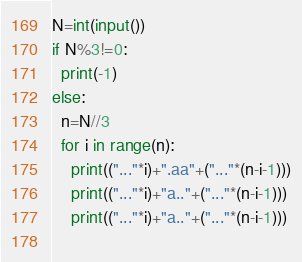Convert code to text. <code><loc_0><loc_0><loc_500><loc_500><_Python_>N=int(input())
if N%3!=0:
  print(-1)
else:
  n=N//3
  for i in range(n):
    print(("..."*i)+".aa"+("..."*(n-i-1)))
    print(("..."*i)+"a.."+("..."*(n-i-1)))
    print(("..."*i)+"a.."+("..."*(n-i-1)))
      </code> 